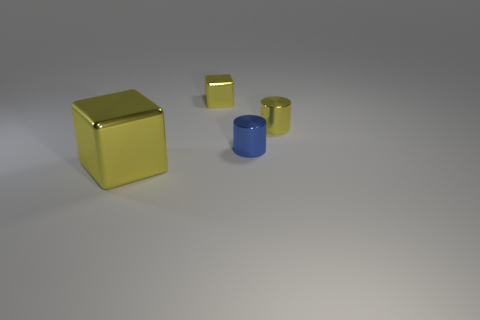What textures are visible on the surfaces of the yellow and blue objects? The surfaces of both the yellow and blue objects have a smooth texture with a reflective metallic appearance, suggesting they are likely made out of a polished metal or similar material. 